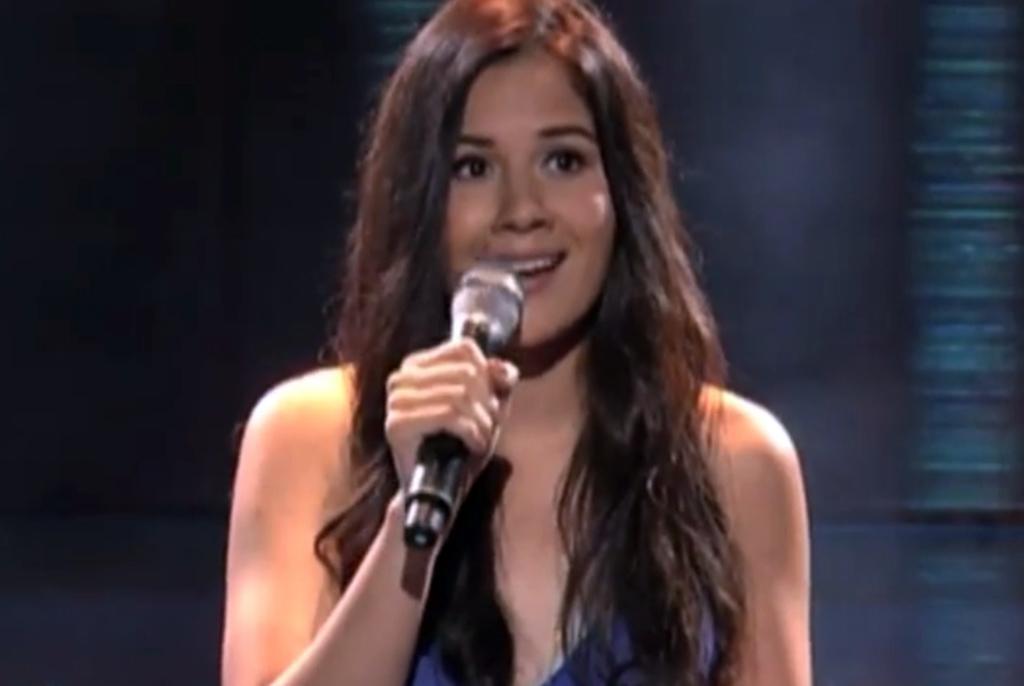Can you describe this image briefly? As we can see in the image there is a woman wearing blue color dress and holding a mic. 